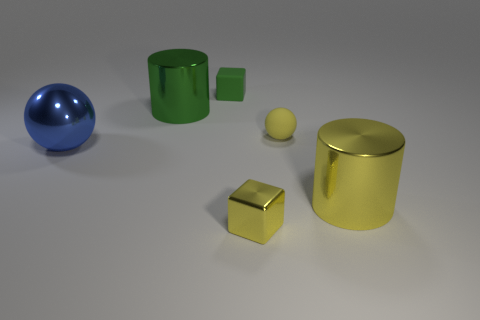What size is the block that is behind the small yellow object that is behind the shiny thing that is to the left of the large green shiny object?
Give a very brief answer. Small. How many matte objects are either large cyan cubes or big blue objects?
Keep it short and to the point. 0. Is the shape of the small green object the same as the tiny metallic thing that is to the right of the green metal cylinder?
Give a very brief answer. Yes. Are there more small green cubes that are in front of the large yellow cylinder than cylinders in front of the large green cylinder?
Your response must be concise. No. Are there any other things that are the same color as the metal block?
Offer a terse response. Yes. There is a small block in front of the large metallic cylinder on the right side of the tiny shiny block; is there a green matte thing to the left of it?
Your response must be concise. Yes. There is a yellow object that is on the left side of the tiny sphere; does it have the same shape as the blue object?
Keep it short and to the point. No. Is the number of yellow metallic blocks that are right of the large yellow shiny thing less than the number of green metallic cylinders behind the tiny sphere?
Ensure brevity in your answer.  Yes. What is the green cylinder made of?
Provide a succinct answer. Metal. Is the color of the small matte cube the same as the cylinder to the left of the small yellow matte object?
Make the answer very short. Yes. 